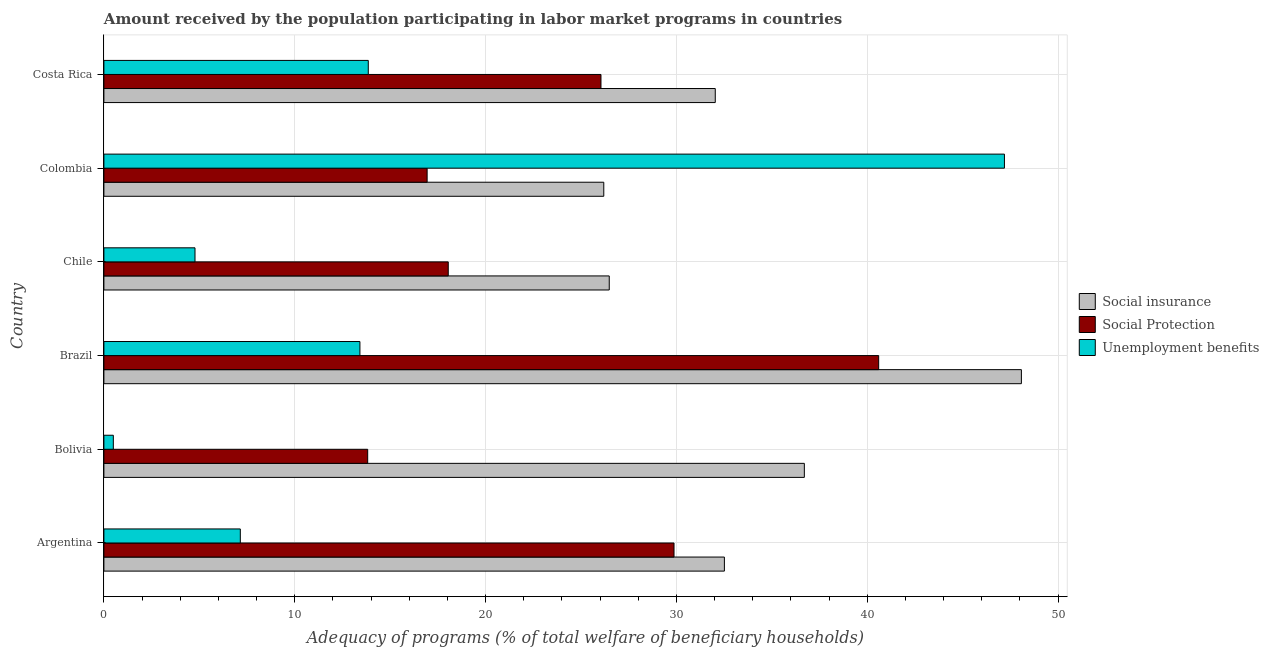How many different coloured bars are there?
Offer a very short reply. 3. How many groups of bars are there?
Your answer should be compact. 6. Are the number of bars per tick equal to the number of legend labels?
Ensure brevity in your answer.  Yes. Are the number of bars on each tick of the Y-axis equal?
Your response must be concise. Yes. How many bars are there on the 2nd tick from the bottom?
Ensure brevity in your answer.  3. What is the amount received by the population participating in unemployment benefits programs in Bolivia?
Make the answer very short. 0.49. Across all countries, what is the maximum amount received by the population participating in unemployment benefits programs?
Give a very brief answer. 47.19. Across all countries, what is the minimum amount received by the population participating in social insurance programs?
Provide a succinct answer. 26.2. In which country was the amount received by the population participating in social protection programs minimum?
Your answer should be very brief. Bolivia. What is the total amount received by the population participating in social insurance programs in the graph?
Provide a short and direct response. 202.02. What is the difference between the amount received by the population participating in unemployment benefits programs in Colombia and that in Costa Rica?
Provide a short and direct response. 33.34. What is the difference between the amount received by the population participating in social insurance programs in Argentina and the amount received by the population participating in social protection programs in Colombia?
Your answer should be compact. 15.58. What is the average amount received by the population participating in unemployment benefits programs per country?
Ensure brevity in your answer.  14.48. What is the difference between the amount received by the population participating in social protection programs and amount received by the population participating in social insurance programs in Argentina?
Your answer should be very brief. -2.64. In how many countries, is the amount received by the population participating in social protection programs greater than 22 %?
Keep it short and to the point. 3. What is the ratio of the amount received by the population participating in unemployment benefits programs in Argentina to that in Bolivia?
Offer a terse response. 14.47. What is the difference between the highest and the second highest amount received by the population participating in social protection programs?
Your answer should be very brief. 10.72. What is the difference between the highest and the lowest amount received by the population participating in unemployment benefits programs?
Keep it short and to the point. 46.7. In how many countries, is the amount received by the population participating in social insurance programs greater than the average amount received by the population participating in social insurance programs taken over all countries?
Keep it short and to the point. 2. What does the 2nd bar from the top in Chile represents?
Your response must be concise. Social Protection. What does the 1st bar from the bottom in Argentina represents?
Make the answer very short. Social insurance. Is it the case that in every country, the sum of the amount received by the population participating in social insurance programs and amount received by the population participating in social protection programs is greater than the amount received by the population participating in unemployment benefits programs?
Ensure brevity in your answer.  No. Are the values on the major ticks of X-axis written in scientific E-notation?
Provide a succinct answer. No. Does the graph contain any zero values?
Make the answer very short. No. Does the graph contain grids?
Your answer should be compact. Yes. How are the legend labels stacked?
Provide a succinct answer. Vertical. What is the title of the graph?
Offer a terse response. Amount received by the population participating in labor market programs in countries. What is the label or title of the X-axis?
Keep it short and to the point. Adequacy of programs (% of total welfare of beneficiary households). What is the Adequacy of programs (% of total welfare of beneficiary households) in Social insurance in Argentina?
Provide a succinct answer. 32.52. What is the Adequacy of programs (% of total welfare of beneficiary households) of Social Protection in Argentina?
Provide a succinct answer. 29.88. What is the Adequacy of programs (% of total welfare of beneficiary households) of Unemployment benefits in Argentina?
Your answer should be very brief. 7.15. What is the Adequacy of programs (% of total welfare of beneficiary households) in Social insurance in Bolivia?
Make the answer very short. 36.71. What is the Adequacy of programs (% of total welfare of beneficiary households) in Social Protection in Bolivia?
Your answer should be compact. 13.82. What is the Adequacy of programs (% of total welfare of beneficiary households) in Unemployment benefits in Bolivia?
Your response must be concise. 0.49. What is the Adequacy of programs (% of total welfare of beneficiary households) in Social insurance in Brazil?
Offer a very short reply. 48.08. What is the Adequacy of programs (% of total welfare of beneficiary households) of Social Protection in Brazil?
Keep it short and to the point. 40.6. What is the Adequacy of programs (% of total welfare of beneficiary households) in Unemployment benefits in Brazil?
Your answer should be very brief. 13.42. What is the Adequacy of programs (% of total welfare of beneficiary households) in Social insurance in Chile?
Your answer should be very brief. 26.48. What is the Adequacy of programs (% of total welfare of beneficiary households) of Social Protection in Chile?
Your response must be concise. 18.05. What is the Adequacy of programs (% of total welfare of beneficiary households) in Unemployment benefits in Chile?
Give a very brief answer. 4.77. What is the Adequacy of programs (% of total welfare of beneficiary households) in Social insurance in Colombia?
Your response must be concise. 26.2. What is the Adequacy of programs (% of total welfare of beneficiary households) of Social Protection in Colombia?
Make the answer very short. 16.94. What is the Adequacy of programs (% of total welfare of beneficiary households) in Unemployment benefits in Colombia?
Offer a very short reply. 47.19. What is the Adequacy of programs (% of total welfare of beneficiary households) of Social insurance in Costa Rica?
Offer a terse response. 32.04. What is the Adequacy of programs (% of total welfare of beneficiary households) in Social Protection in Costa Rica?
Give a very brief answer. 26.05. What is the Adequacy of programs (% of total welfare of beneficiary households) in Unemployment benefits in Costa Rica?
Ensure brevity in your answer.  13.85. Across all countries, what is the maximum Adequacy of programs (% of total welfare of beneficiary households) in Social insurance?
Ensure brevity in your answer.  48.08. Across all countries, what is the maximum Adequacy of programs (% of total welfare of beneficiary households) in Social Protection?
Ensure brevity in your answer.  40.6. Across all countries, what is the maximum Adequacy of programs (% of total welfare of beneficiary households) of Unemployment benefits?
Keep it short and to the point. 47.19. Across all countries, what is the minimum Adequacy of programs (% of total welfare of beneficiary households) of Social insurance?
Your response must be concise. 26.2. Across all countries, what is the minimum Adequacy of programs (% of total welfare of beneficiary households) of Social Protection?
Your answer should be very brief. 13.82. Across all countries, what is the minimum Adequacy of programs (% of total welfare of beneficiary households) of Unemployment benefits?
Provide a succinct answer. 0.49. What is the total Adequacy of programs (% of total welfare of beneficiary households) in Social insurance in the graph?
Make the answer very short. 202.02. What is the total Adequacy of programs (% of total welfare of beneficiary households) in Social Protection in the graph?
Ensure brevity in your answer.  145.34. What is the total Adequacy of programs (% of total welfare of beneficiary households) of Unemployment benefits in the graph?
Provide a short and direct response. 86.88. What is the difference between the Adequacy of programs (% of total welfare of beneficiary households) in Social insurance in Argentina and that in Bolivia?
Your answer should be compact. -4.19. What is the difference between the Adequacy of programs (% of total welfare of beneficiary households) of Social Protection in Argentina and that in Bolivia?
Your answer should be very brief. 16.05. What is the difference between the Adequacy of programs (% of total welfare of beneficiary households) of Unemployment benefits in Argentina and that in Bolivia?
Ensure brevity in your answer.  6.65. What is the difference between the Adequacy of programs (% of total welfare of beneficiary households) in Social insurance in Argentina and that in Brazil?
Offer a terse response. -15.56. What is the difference between the Adequacy of programs (% of total welfare of beneficiary households) of Social Protection in Argentina and that in Brazil?
Offer a terse response. -10.72. What is the difference between the Adequacy of programs (% of total welfare of beneficiary households) in Unemployment benefits in Argentina and that in Brazil?
Give a very brief answer. -6.27. What is the difference between the Adequacy of programs (% of total welfare of beneficiary households) in Social insurance in Argentina and that in Chile?
Your answer should be compact. 6.03. What is the difference between the Adequacy of programs (% of total welfare of beneficiary households) of Social Protection in Argentina and that in Chile?
Keep it short and to the point. 11.83. What is the difference between the Adequacy of programs (% of total welfare of beneficiary households) of Unemployment benefits in Argentina and that in Chile?
Offer a terse response. 2.37. What is the difference between the Adequacy of programs (% of total welfare of beneficiary households) of Social insurance in Argentina and that in Colombia?
Give a very brief answer. 6.32. What is the difference between the Adequacy of programs (% of total welfare of beneficiary households) in Social Protection in Argentina and that in Colombia?
Ensure brevity in your answer.  12.94. What is the difference between the Adequacy of programs (% of total welfare of beneficiary households) in Unemployment benefits in Argentina and that in Colombia?
Keep it short and to the point. -40.04. What is the difference between the Adequacy of programs (% of total welfare of beneficiary households) in Social insurance in Argentina and that in Costa Rica?
Your answer should be compact. 0.48. What is the difference between the Adequacy of programs (% of total welfare of beneficiary households) in Social Protection in Argentina and that in Costa Rica?
Make the answer very short. 3.83. What is the difference between the Adequacy of programs (% of total welfare of beneficiary households) in Unemployment benefits in Argentina and that in Costa Rica?
Your response must be concise. -6.71. What is the difference between the Adequacy of programs (% of total welfare of beneficiary households) in Social insurance in Bolivia and that in Brazil?
Give a very brief answer. -11.37. What is the difference between the Adequacy of programs (% of total welfare of beneficiary households) of Social Protection in Bolivia and that in Brazil?
Offer a very short reply. -26.78. What is the difference between the Adequacy of programs (% of total welfare of beneficiary households) in Unemployment benefits in Bolivia and that in Brazil?
Ensure brevity in your answer.  -12.92. What is the difference between the Adequacy of programs (% of total welfare of beneficiary households) of Social insurance in Bolivia and that in Chile?
Your answer should be compact. 10.22. What is the difference between the Adequacy of programs (% of total welfare of beneficiary households) of Social Protection in Bolivia and that in Chile?
Keep it short and to the point. -4.22. What is the difference between the Adequacy of programs (% of total welfare of beneficiary households) of Unemployment benefits in Bolivia and that in Chile?
Ensure brevity in your answer.  -4.28. What is the difference between the Adequacy of programs (% of total welfare of beneficiary households) in Social insurance in Bolivia and that in Colombia?
Give a very brief answer. 10.51. What is the difference between the Adequacy of programs (% of total welfare of beneficiary households) in Social Protection in Bolivia and that in Colombia?
Your answer should be compact. -3.11. What is the difference between the Adequacy of programs (% of total welfare of beneficiary households) of Unemployment benefits in Bolivia and that in Colombia?
Keep it short and to the point. -46.7. What is the difference between the Adequacy of programs (% of total welfare of beneficiary households) of Social insurance in Bolivia and that in Costa Rica?
Your response must be concise. 4.67. What is the difference between the Adequacy of programs (% of total welfare of beneficiary households) in Social Protection in Bolivia and that in Costa Rica?
Your answer should be very brief. -12.22. What is the difference between the Adequacy of programs (% of total welfare of beneficiary households) in Unemployment benefits in Bolivia and that in Costa Rica?
Ensure brevity in your answer.  -13.36. What is the difference between the Adequacy of programs (% of total welfare of beneficiary households) in Social insurance in Brazil and that in Chile?
Provide a short and direct response. 21.6. What is the difference between the Adequacy of programs (% of total welfare of beneficiary households) of Social Protection in Brazil and that in Chile?
Your response must be concise. 22.56. What is the difference between the Adequacy of programs (% of total welfare of beneficiary households) in Unemployment benefits in Brazil and that in Chile?
Offer a terse response. 8.64. What is the difference between the Adequacy of programs (% of total welfare of beneficiary households) in Social insurance in Brazil and that in Colombia?
Your response must be concise. 21.88. What is the difference between the Adequacy of programs (% of total welfare of beneficiary households) of Social Protection in Brazil and that in Colombia?
Offer a terse response. 23.66. What is the difference between the Adequacy of programs (% of total welfare of beneficiary households) in Unemployment benefits in Brazil and that in Colombia?
Ensure brevity in your answer.  -33.77. What is the difference between the Adequacy of programs (% of total welfare of beneficiary households) in Social insurance in Brazil and that in Costa Rica?
Ensure brevity in your answer.  16.04. What is the difference between the Adequacy of programs (% of total welfare of beneficiary households) of Social Protection in Brazil and that in Costa Rica?
Provide a short and direct response. 14.55. What is the difference between the Adequacy of programs (% of total welfare of beneficiary households) in Unemployment benefits in Brazil and that in Costa Rica?
Provide a short and direct response. -0.44. What is the difference between the Adequacy of programs (% of total welfare of beneficiary households) in Social insurance in Chile and that in Colombia?
Your answer should be compact. 0.29. What is the difference between the Adequacy of programs (% of total welfare of beneficiary households) of Social Protection in Chile and that in Colombia?
Offer a terse response. 1.11. What is the difference between the Adequacy of programs (% of total welfare of beneficiary households) of Unemployment benefits in Chile and that in Colombia?
Your answer should be compact. -42.42. What is the difference between the Adequacy of programs (% of total welfare of beneficiary households) of Social insurance in Chile and that in Costa Rica?
Your response must be concise. -5.56. What is the difference between the Adequacy of programs (% of total welfare of beneficiary households) in Social Protection in Chile and that in Costa Rica?
Your response must be concise. -8. What is the difference between the Adequacy of programs (% of total welfare of beneficiary households) of Unemployment benefits in Chile and that in Costa Rica?
Give a very brief answer. -9.08. What is the difference between the Adequacy of programs (% of total welfare of beneficiary households) of Social insurance in Colombia and that in Costa Rica?
Offer a very short reply. -5.84. What is the difference between the Adequacy of programs (% of total welfare of beneficiary households) of Social Protection in Colombia and that in Costa Rica?
Your answer should be compact. -9.11. What is the difference between the Adequacy of programs (% of total welfare of beneficiary households) in Unemployment benefits in Colombia and that in Costa Rica?
Ensure brevity in your answer.  33.34. What is the difference between the Adequacy of programs (% of total welfare of beneficiary households) of Social insurance in Argentina and the Adequacy of programs (% of total welfare of beneficiary households) of Social Protection in Bolivia?
Ensure brevity in your answer.  18.69. What is the difference between the Adequacy of programs (% of total welfare of beneficiary households) in Social insurance in Argentina and the Adequacy of programs (% of total welfare of beneficiary households) in Unemployment benefits in Bolivia?
Offer a very short reply. 32.02. What is the difference between the Adequacy of programs (% of total welfare of beneficiary households) in Social Protection in Argentina and the Adequacy of programs (% of total welfare of beneficiary households) in Unemployment benefits in Bolivia?
Ensure brevity in your answer.  29.38. What is the difference between the Adequacy of programs (% of total welfare of beneficiary households) in Social insurance in Argentina and the Adequacy of programs (% of total welfare of beneficiary households) in Social Protection in Brazil?
Ensure brevity in your answer.  -8.09. What is the difference between the Adequacy of programs (% of total welfare of beneficiary households) in Social insurance in Argentina and the Adequacy of programs (% of total welfare of beneficiary households) in Unemployment benefits in Brazil?
Provide a succinct answer. 19.1. What is the difference between the Adequacy of programs (% of total welfare of beneficiary households) in Social Protection in Argentina and the Adequacy of programs (% of total welfare of beneficiary households) in Unemployment benefits in Brazil?
Give a very brief answer. 16.46. What is the difference between the Adequacy of programs (% of total welfare of beneficiary households) of Social insurance in Argentina and the Adequacy of programs (% of total welfare of beneficiary households) of Social Protection in Chile?
Ensure brevity in your answer.  14.47. What is the difference between the Adequacy of programs (% of total welfare of beneficiary households) of Social insurance in Argentina and the Adequacy of programs (% of total welfare of beneficiary households) of Unemployment benefits in Chile?
Ensure brevity in your answer.  27.74. What is the difference between the Adequacy of programs (% of total welfare of beneficiary households) in Social Protection in Argentina and the Adequacy of programs (% of total welfare of beneficiary households) in Unemployment benefits in Chile?
Give a very brief answer. 25.1. What is the difference between the Adequacy of programs (% of total welfare of beneficiary households) of Social insurance in Argentina and the Adequacy of programs (% of total welfare of beneficiary households) of Social Protection in Colombia?
Offer a terse response. 15.58. What is the difference between the Adequacy of programs (% of total welfare of beneficiary households) in Social insurance in Argentina and the Adequacy of programs (% of total welfare of beneficiary households) in Unemployment benefits in Colombia?
Your answer should be very brief. -14.68. What is the difference between the Adequacy of programs (% of total welfare of beneficiary households) of Social Protection in Argentina and the Adequacy of programs (% of total welfare of beneficiary households) of Unemployment benefits in Colombia?
Provide a succinct answer. -17.32. What is the difference between the Adequacy of programs (% of total welfare of beneficiary households) in Social insurance in Argentina and the Adequacy of programs (% of total welfare of beneficiary households) in Social Protection in Costa Rica?
Give a very brief answer. 6.47. What is the difference between the Adequacy of programs (% of total welfare of beneficiary households) of Social insurance in Argentina and the Adequacy of programs (% of total welfare of beneficiary households) of Unemployment benefits in Costa Rica?
Your answer should be very brief. 18.66. What is the difference between the Adequacy of programs (% of total welfare of beneficiary households) of Social Protection in Argentina and the Adequacy of programs (% of total welfare of beneficiary households) of Unemployment benefits in Costa Rica?
Provide a succinct answer. 16.02. What is the difference between the Adequacy of programs (% of total welfare of beneficiary households) of Social insurance in Bolivia and the Adequacy of programs (% of total welfare of beneficiary households) of Social Protection in Brazil?
Provide a succinct answer. -3.9. What is the difference between the Adequacy of programs (% of total welfare of beneficiary households) of Social insurance in Bolivia and the Adequacy of programs (% of total welfare of beneficiary households) of Unemployment benefits in Brazil?
Your answer should be very brief. 23.29. What is the difference between the Adequacy of programs (% of total welfare of beneficiary households) in Social Protection in Bolivia and the Adequacy of programs (% of total welfare of beneficiary households) in Unemployment benefits in Brazil?
Provide a short and direct response. 0.41. What is the difference between the Adequacy of programs (% of total welfare of beneficiary households) in Social insurance in Bolivia and the Adequacy of programs (% of total welfare of beneficiary households) in Social Protection in Chile?
Your answer should be very brief. 18.66. What is the difference between the Adequacy of programs (% of total welfare of beneficiary households) of Social insurance in Bolivia and the Adequacy of programs (% of total welfare of beneficiary households) of Unemployment benefits in Chile?
Make the answer very short. 31.93. What is the difference between the Adequacy of programs (% of total welfare of beneficiary households) of Social Protection in Bolivia and the Adequacy of programs (% of total welfare of beneficiary households) of Unemployment benefits in Chile?
Offer a terse response. 9.05. What is the difference between the Adequacy of programs (% of total welfare of beneficiary households) of Social insurance in Bolivia and the Adequacy of programs (% of total welfare of beneficiary households) of Social Protection in Colombia?
Your response must be concise. 19.77. What is the difference between the Adequacy of programs (% of total welfare of beneficiary households) of Social insurance in Bolivia and the Adequacy of programs (% of total welfare of beneficiary households) of Unemployment benefits in Colombia?
Provide a succinct answer. -10.49. What is the difference between the Adequacy of programs (% of total welfare of beneficiary households) of Social Protection in Bolivia and the Adequacy of programs (% of total welfare of beneficiary households) of Unemployment benefits in Colombia?
Make the answer very short. -33.37. What is the difference between the Adequacy of programs (% of total welfare of beneficiary households) in Social insurance in Bolivia and the Adequacy of programs (% of total welfare of beneficiary households) in Social Protection in Costa Rica?
Your response must be concise. 10.66. What is the difference between the Adequacy of programs (% of total welfare of beneficiary households) of Social insurance in Bolivia and the Adequacy of programs (% of total welfare of beneficiary households) of Unemployment benefits in Costa Rica?
Offer a very short reply. 22.85. What is the difference between the Adequacy of programs (% of total welfare of beneficiary households) in Social Protection in Bolivia and the Adequacy of programs (% of total welfare of beneficiary households) in Unemployment benefits in Costa Rica?
Offer a terse response. -0.03. What is the difference between the Adequacy of programs (% of total welfare of beneficiary households) in Social insurance in Brazil and the Adequacy of programs (% of total welfare of beneficiary households) in Social Protection in Chile?
Keep it short and to the point. 30.04. What is the difference between the Adequacy of programs (% of total welfare of beneficiary households) in Social insurance in Brazil and the Adequacy of programs (% of total welfare of beneficiary households) in Unemployment benefits in Chile?
Your answer should be compact. 43.31. What is the difference between the Adequacy of programs (% of total welfare of beneficiary households) in Social Protection in Brazil and the Adequacy of programs (% of total welfare of beneficiary households) in Unemployment benefits in Chile?
Provide a succinct answer. 35.83. What is the difference between the Adequacy of programs (% of total welfare of beneficiary households) in Social insurance in Brazil and the Adequacy of programs (% of total welfare of beneficiary households) in Social Protection in Colombia?
Offer a very short reply. 31.14. What is the difference between the Adequacy of programs (% of total welfare of beneficiary households) in Social insurance in Brazil and the Adequacy of programs (% of total welfare of beneficiary households) in Unemployment benefits in Colombia?
Provide a succinct answer. 0.89. What is the difference between the Adequacy of programs (% of total welfare of beneficiary households) in Social Protection in Brazil and the Adequacy of programs (% of total welfare of beneficiary households) in Unemployment benefits in Colombia?
Your answer should be compact. -6.59. What is the difference between the Adequacy of programs (% of total welfare of beneficiary households) in Social insurance in Brazil and the Adequacy of programs (% of total welfare of beneficiary households) in Social Protection in Costa Rica?
Your answer should be very brief. 22.03. What is the difference between the Adequacy of programs (% of total welfare of beneficiary households) in Social insurance in Brazil and the Adequacy of programs (% of total welfare of beneficiary households) in Unemployment benefits in Costa Rica?
Your answer should be very brief. 34.23. What is the difference between the Adequacy of programs (% of total welfare of beneficiary households) in Social Protection in Brazil and the Adequacy of programs (% of total welfare of beneficiary households) in Unemployment benefits in Costa Rica?
Offer a terse response. 26.75. What is the difference between the Adequacy of programs (% of total welfare of beneficiary households) of Social insurance in Chile and the Adequacy of programs (% of total welfare of beneficiary households) of Social Protection in Colombia?
Offer a terse response. 9.54. What is the difference between the Adequacy of programs (% of total welfare of beneficiary households) of Social insurance in Chile and the Adequacy of programs (% of total welfare of beneficiary households) of Unemployment benefits in Colombia?
Provide a succinct answer. -20.71. What is the difference between the Adequacy of programs (% of total welfare of beneficiary households) in Social Protection in Chile and the Adequacy of programs (% of total welfare of beneficiary households) in Unemployment benefits in Colombia?
Make the answer very short. -29.15. What is the difference between the Adequacy of programs (% of total welfare of beneficiary households) in Social insurance in Chile and the Adequacy of programs (% of total welfare of beneficiary households) in Social Protection in Costa Rica?
Your answer should be very brief. 0.43. What is the difference between the Adequacy of programs (% of total welfare of beneficiary households) of Social insurance in Chile and the Adequacy of programs (% of total welfare of beneficiary households) of Unemployment benefits in Costa Rica?
Your answer should be very brief. 12.63. What is the difference between the Adequacy of programs (% of total welfare of beneficiary households) in Social Protection in Chile and the Adequacy of programs (% of total welfare of beneficiary households) in Unemployment benefits in Costa Rica?
Give a very brief answer. 4.19. What is the difference between the Adequacy of programs (% of total welfare of beneficiary households) of Social insurance in Colombia and the Adequacy of programs (% of total welfare of beneficiary households) of Social Protection in Costa Rica?
Make the answer very short. 0.15. What is the difference between the Adequacy of programs (% of total welfare of beneficiary households) in Social insurance in Colombia and the Adequacy of programs (% of total welfare of beneficiary households) in Unemployment benefits in Costa Rica?
Offer a very short reply. 12.34. What is the difference between the Adequacy of programs (% of total welfare of beneficiary households) in Social Protection in Colombia and the Adequacy of programs (% of total welfare of beneficiary households) in Unemployment benefits in Costa Rica?
Provide a succinct answer. 3.08. What is the average Adequacy of programs (% of total welfare of beneficiary households) of Social insurance per country?
Keep it short and to the point. 33.67. What is the average Adequacy of programs (% of total welfare of beneficiary households) of Social Protection per country?
Your response must be concise. 24.22. What is the average Adequacy of programs (% of total welfare of beneficiary households) of Unemployment benefits per country?
Keep it short and to the point. 14.48. What is the difference between the Adequacy of programs (% of total welfare of beneficiary households) of Social insurance and Adequacy of programs (% of total welfare of beneficiary households) of Social Protection in Argentina?
Provide a succinct answer. 2.64. What is the difference between the Adequacy of programs (% of total welfare of beneficiary households) in Social insurance and Adequacy of programs (% of total welfare of beneficiary households) in Unemployment benefits in Argentina?
Provide a short and direct response. 25.37. What is the difference between the Adequacy of programs (% of total welfare of beneficiary households) in Social Protection and Adequacy of programs (% of total welfare of beneficiary households) in Unemployment benefits in Argentina?
Your response must be concise. 22.73. What is the difference between the Adequacy of programs (% of total welfare of beneficiary households) of Social insurance and Adequacy of programs (% of total welfare of beneficiary households) of Social Protection in Bolivia?
Offer a terse response. 22.88. What is the difference between the Adequacy of programs (% of total welfare of beneficiary households) in Social insurance and Adequacy of programs (% of total welfare of beneficiary households) in Unemployment benefits in Bolivia?
Provide a succinct answer. 36.21. What is the difference between the Adequacy of programs (% of total welfare of beneficiary households) in Social Protection and Adequacy of programs (% of total welfare of beneficiary households) in Unemployment benefits in Bolivia?
Ensure brevity in your answer.  13.33. What is the difference between the Adequacy of programs (% of total welfare of beneficiary households) in Social insurance and Adequacy of programs (% of total welfare of beneficiary households) in Social Protection in Brazil?
Provide a succinct answer. 7.48. What is the difference between the Adequacy of programs (% of total welfare of beneficiary households) in Social insurance and Adequacy of programs (% of total welfare of beneficiary households) in Unemployment benefits in Brazil?
Provide a succinct answer. 34.66. What is the difference between the Adequacy of programs (% of total welfare of beneficiary households) of Social Protection and Adequacy of programs (% of total welfare of beneficiary households) of Unemployment benefits in Brazil?
Your response must be concise. 27.18. What is the difference between the Adequacy of programs (% of total welfare of beneficiary households) of Social insurance and Adequacy of programs (% of total welfare of beneficiary households) of Social Protection in Chile?
Provide a succinct answer. 8.44. What is the difference between the Adequacy of programs (% of total welfare of beneficiary households) in Social insurance and Adequacy of programs (% of total welfare of beneficiary households) in Unemployment benefits in Chile?
Provide a succinct answer. 21.71. What is the difference between the Adequacy of programs (% of total welfare of beneficiary households) in Social Protection and Adequacy of programs (% of total welfare of beneficiary households) in Unemployment benefits in Chile?
Your response must be concise. 13.27. What is the difference between the Adequacy of programs (% of total welfare of beneficiary households) in Social insurance and Adequacy of programs (% of total welfare of beneficiary households) in Social Protection in Colombia?
Your response must be concise. 9.26. What is the difference between the Adequacy of programs (% of total welfare of beneficiary households) in Social insurance and Adequacy of programs (% of total welfare of beneficiary households) in Unemployment benefits in Colombia?
Provide a succinct answer. -21. What is the difference between the Adequacy of programs (% of total welfare of beneficiary households) of Social Protection and Adequacy of programs (% of total welfare of beneficiary households) of Unemployment benefits in Colombia?
Make the answer very short. -30.25. What is the difference between the Adequacy of programs (% of total welfare of beneficiary households) in Social insurance and Adequacy of programs (% of total welfare of beneficiary households) in Social Protection in Costa Rica?
Your answer should be very brief. 5.99. What is the difference between the Adequacy of programs (% of total welfare of beneficiary households) in Social insurance and Adequacy of programs (% of total welfare of beneficiary households) in Unemployment benefits in Costa Rica?
Your answer should be compact. 18.18. What is the difference between the Adequacy of programs (% of total welfare of beneficiary households) of Social Protection and Adequacy of programs (% of total welfare of beneficiary households) of Unemployment benefits in Costa Rica?
Your answer should be very brief. 12.19. What is the ratio of the Adequacy of programs (% of total welfare of beneficiary households) in Social insurance in Argentina to that in Bolivia?
Give a very brief answer. 0.89. What is the ratio of the Adequacy of programs (% of total welfare of beneficiary households) in Social Protection in Argentina to that in Bolivia?
Your response must be concise. 2.16. What is the ratio of the Adequacy of programs (% of total welfare of beneficiary households) of Unemployment benefits in Argentina to that in Bolivia?
Provide a succinct answer. 14.47. What is the ratio of the Adequacy of programs (% of total welfare of beneficiary households) in Social insurance in Argentina to that in Brazil?
Provide a succinct answer. 0.68. What is the ratio of the Adequacy of programs (% of total welfare of beneficiary households) in Social Protection in Argentina to that in Brazil?
Offer a very short reply. 0.74. What is the ratio of the Adequacy of programs (% of total welfare of beneficiary households) in Unemployment benefits in Argentina to that in Brazil?
Your answer should be compact. 0.53. What is the ratio of the Adequacy of programs (% of total welfare of beneficiary households) of Social insurance in Argentina to that in Chile?
Offer a terse response. 1.23. What is the ratio of the Adequacy of programs (% of total welfare of beneficiary households) in Social Protection in Argentina to that in Chile?
Give a very brief answer. 1.66. What is the ratio of the Adequacy of programs (% of total welfare of beneficiary households) of Unemployment benefits in Argentina to that in Chile?
Your response must be concise. 1.5. What is the ratio of the Adequacy of programs (% of total welfare of beneficiary households) of Social insurance in Argentina to that in Colombia?
Your response must be concise. 1.24. What is the ratio of the Adequacy of programs (% of total welfare of beneficiary households) in Social Protection in Argentina to that in Colombia?
Offer a very short reply. 1.76. What is the ratio of the Adequacy of programs (% of total welfare of beneficiary households) of Unemployment benefits in Argentina to that in Colombia?
Provide a succinct answer. 0.15. What is the ratio of the Adequacy of programs (% of total welfare of beneficiary households) of Social insurance in Argentina to that in Costa Rica?
Keep it short and to the point. 1.01. What is the ratio of the Adequacy of programs (% of total welfare of beneficiary households) in Social Protection in Argentina to that in Costa Rica?
Your answer should be very brief. 1.15. What is the ratio of the Adequacy of programs (% of total welfare of beneficiary households) in Unemployment benefits in Argentina to that in Costa Rica?
Offer a terse response. 0.52. What is the ratio of the Adequacy of programs (% of total welfare of beneficiary households) of Social insurance in Bolivia to that in Brazil?
Your answer should be very brief. 0.76. What is the ratio of the Adequacy of programs (% of total welfare of beneficiary households) of Social Protection in Bolivia to that in Brazil?
Your response must be concise. 0.34. What is the ratio of the Adequacy of programs (% of total welfare of beneficiary households) of Unemployment benefits in Bolivia to that in Brazil?
Your response must be concise. 0.04. What is the ratio of the Adequacy of programs (% of total welfare of beneficiary households) of Social insurance in Bolivia to that in Chile?
Your answer should be compact. 1.39. What is the ratio of the Adequacy of programs (% of total welfare of beneficiary households) of Social Protection in Bolivia to that in Chile?
Ensure brevity in your answer.  0.77. What is the ratio of the Adequacy of programs (% of total welfare of beneficiary households) in Unemployment benefits in Bolivia to that in Chile?
Offer a terse response. 0.1. What is the ratio of the Adequacy of programs (% of total welfare of beneficiary households) in Social insurance in Bolivia to that in Colombia?
Your response must be concise. 1.4. What is the ratio of the Adequacy of programs (% of total welfare of beneficiary households) in Social Protection in Bolivia to that in Colombia?
Your response must be concise. 0.82. What is the ratio of the Adequacy of programs (% of total welfare of beneficiary households) of Unemployment benefits in Bolivia to that in Colombia?
Offer a very short reply. 0.01. What is the ratio of the Adequacy of programs (% of total welfare of beneficiary households) in Social insurance in Bolivia to that in Costa Rica?
Your response must be concise. 1.15. What is the ratio of the Adequacy of programs (% of total welfare of beneficiary households) in Social Protection in Bolivia to that in Costa Rica?
Offer a terse response. 0.53. What is the ratio of the Adequacy of programs (% of total welfare of beneficiary households) in Unemployment benefits in Bolivia to that in Costa Rica?
Provide a short and direct response. 0.04. What is the ratio of the Adequacy of programs (% of total welfare of beneficiary households) in Social insurance in Brazil to that in Chile?
Provide a short and direct response. 1.82. What is the ratio of the Adequacy of programs (% of total welfare of beneficiary households) of Social Protection in Brazil to that in Chile?
Give a very brief answer. 2.25. What is the ratio of the Adequacy of programs (% of total welfare of beneficiary households) in Unemployment benefits in Brazil to that in Chile?
Your answer should be very brief. 2.81. What is the ratio of the Adequacy of programs (% of total welfare of beneficiary households) in Social insurance in Brazil to that in Colombia?
Provide a short and direct response. 1.84. What is the ratio of the Adequacy of programs (% of total welfare of beneficiary households) in Social Protection in Brazil to that in Colombia?
Provide a succinct answer. 2.4. What is the ratio of the Adequacy of programs (% of total welfare of beneficiary households) of Unemployment benefits in Brazil to that in Colombia?
Your answer should be very brief. 0.28. What is the ratio of the Adequacy of programs (% of total welfare of beneficiary households) of Social insurance in Brazil to that in Costa Rica?
Give a very brief answer. 1.5. What is the ratio of the Adequacy of programs (% of total welfare of beneficiary households) of Social Protection in Brazil to that in Costa Rica?
Provide a succinct answer. 1.56. What is the ratio of the Adequacy of programs (% of total welfare of beneficiary households) in Unemployment benefits in Brazil to that in Costa Rica?
Ensure brevity in your answer.  0.97. What is the ratio of the Adequacy of programs (% of total welfare of beneficiary households) in Social insurance in Chile to that in Colombia?
Your answer should be very brief. 1.01. What is the ratio of the Adequacy of programs (% of total welfare of beneficiary households) in Social Protection in Chile to that in Colombia?
Your answer should be compact. 1.07. What is the ratio of the Adequacy of programs (% of total welfare of beneficiary households) of Unemployment benefits in Chile to that in Colombia?
Provide a succinct answer. 0.1. What is the ratio of the Adequacy of programs (% of total welfare of beneficiary households) of Social insurance in Chile to that in Costa Rica?
Provide a short and direct response. 0.83. What is the ratio of the Adequacy of programs (% of total welfare of beneficiary households) in Social Protection in Chile to that in Costa Rica?
Your response must be concise. 0.69. What is the ratio of the Adequacy of programs (% of total welfare of beneficiary households) in Unemployment benefits in Chile to that in Costa Rica?
Give a very brief answer. 0.34. What is the ratio of the Adequacy of programs (% of total welfare of beneficiary households) of Social insurance in Colombia to that in Costa Rica?
Provide a short and direct response. 0.82. What is the ratio of the Adequacy of programs (% of total welfare of beneficiary households) in Social Protection in Colombia to that in Costa Rica?
Provide a succinct answer. 0.65. What is the ratio of the Adequacy of programs (% of total welfare of beneficiary households) in Unemployment benefits in Colombia to that in Costa Rica?
Give a very brief answer. 3.41. What is the difference between the highest and the second highest Adequacy of programs (% of total welfare of beneficiary households) of Social insurance?
Give a very brief answer. 11.37. What is the difference between the highest and the second highest Adequacy of programs (% of total welfare of beneficiary households) in Social Protection?
Keep it short and to the point. 10.72. What is the difference between the highest and the second highest Adequacy of programs (% of total welfare of beneficiary households) of Unemployment benefits?
Keep it short and to the point. 33.34. What is the difference between the highest and the lowest Adequacy of programs (% of total welfare of beneficiary households) in Social insurance?
Give a very brief answer. 21.88. What is the difference between the highest and the lowest Adequacy of programs (% of total welfare of beneficiary households) of Social Protection?
Offer a terse response. 26.78. What is the difference between the highest and the lowest Adequacy of programs (% of total welfare of beneficiary households) of Unemployment benefits?
Ensure brevity in your answer.  46.7. 